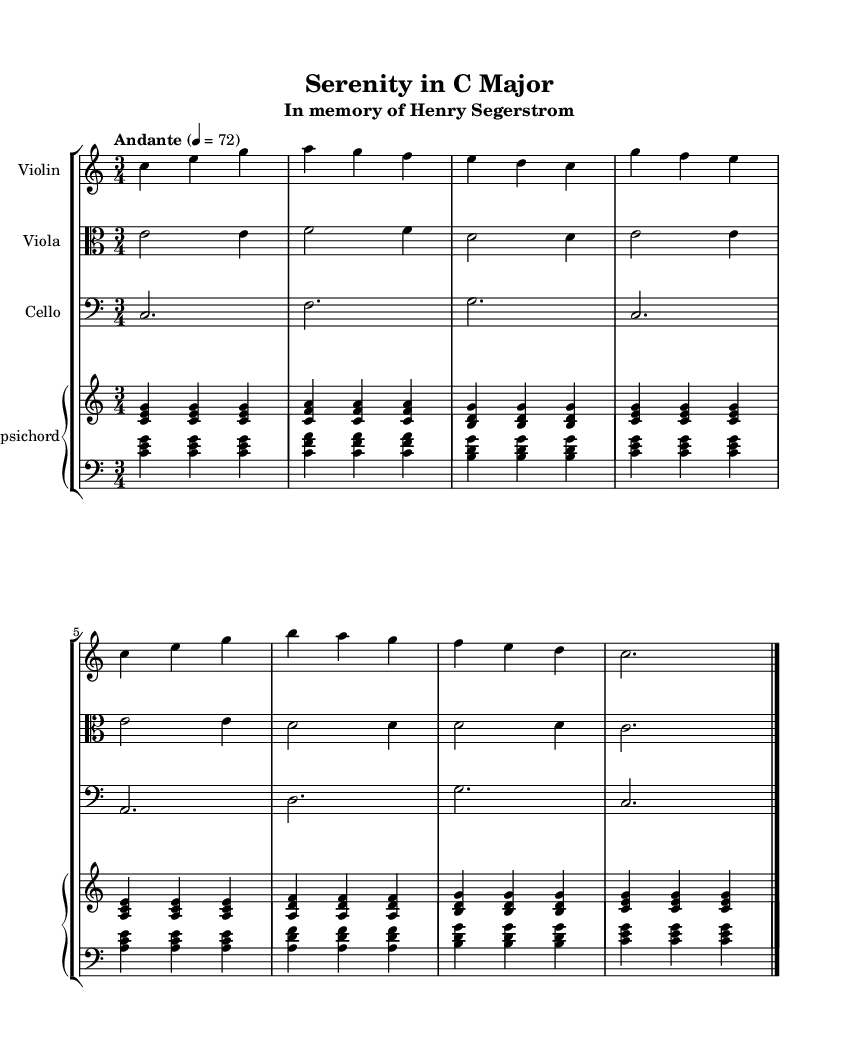What is the key signature of this music? The key signature is indicated by the absence of sharps or flats in the music. Since it is marked as "C major," this confirms there are no accidentals present.
Answer: C major What is the time signature of this music? The time signature is shown at the beginning of the piece, represented by '3/4', indicating there are three beats in a measure and a quarter note receives one beat.
Answer: 3/4 What is the tempo marking for this piece? The tempo marking is written as "Andante" and indicates a moderate pace. The number "4 = 72" shows that the quarter note should count at 72 beats per minute.
Answer: Andante Which instrument has a clef marking of alto? The clef marking of alto is shown in the staff for the viola, which indicates the range of notes the instrument will play.
Answer: Viola How many instruments are present in this score? The score visually displays four different parts: Violin, Viola, Cello, and Harpsichord, making a total of four instruments.
Answer: Four What is the last measure of the cello part? The last measure of the cello part is represented by a half note and is marked with a double bar line to indicate the end of the piece. This shows the conclusion of the music for the cello section.
Answer: c,2 Which notes are played in the first chord of the harpsichord? The first chord of the harpsichord is represented by the notes C, E, and G played together, forming a C major triad in the first measure.
Answer: C, E, G 